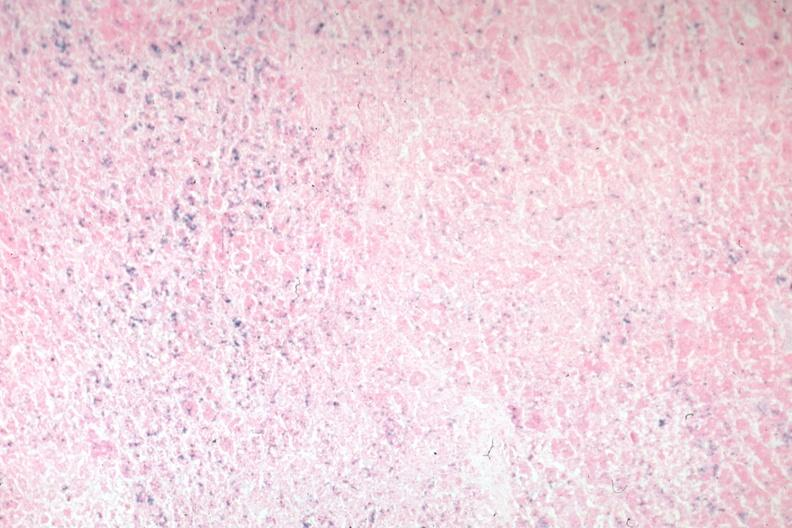s hemochromatosis present?
Answer the question using a single word or phrase. Yes 